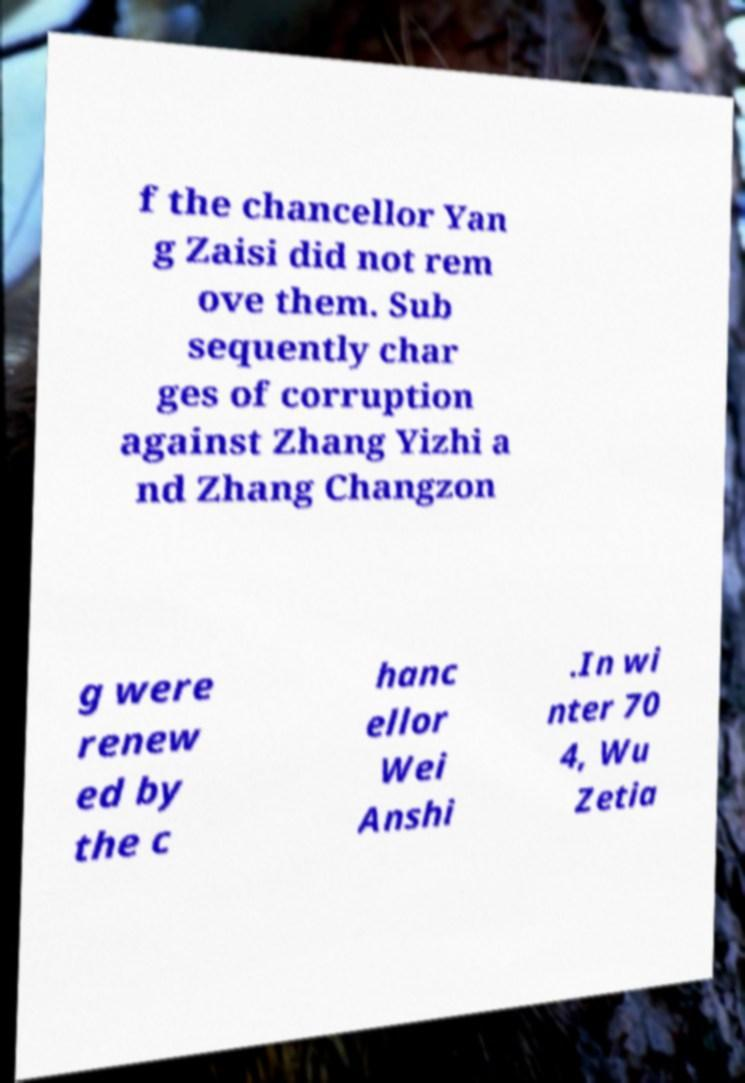What messages or text are displayed in this image? I need them in a readable, typed format. f the chancellor Yan g Zaisi did not rem ove them. Sub sequently char ges of corruption against Zhang Yizhi a nd Zhang Changzon g were renew ed by the c hanc ellor Wei Anshi .In wi nter 70 4, Wu Zetia 